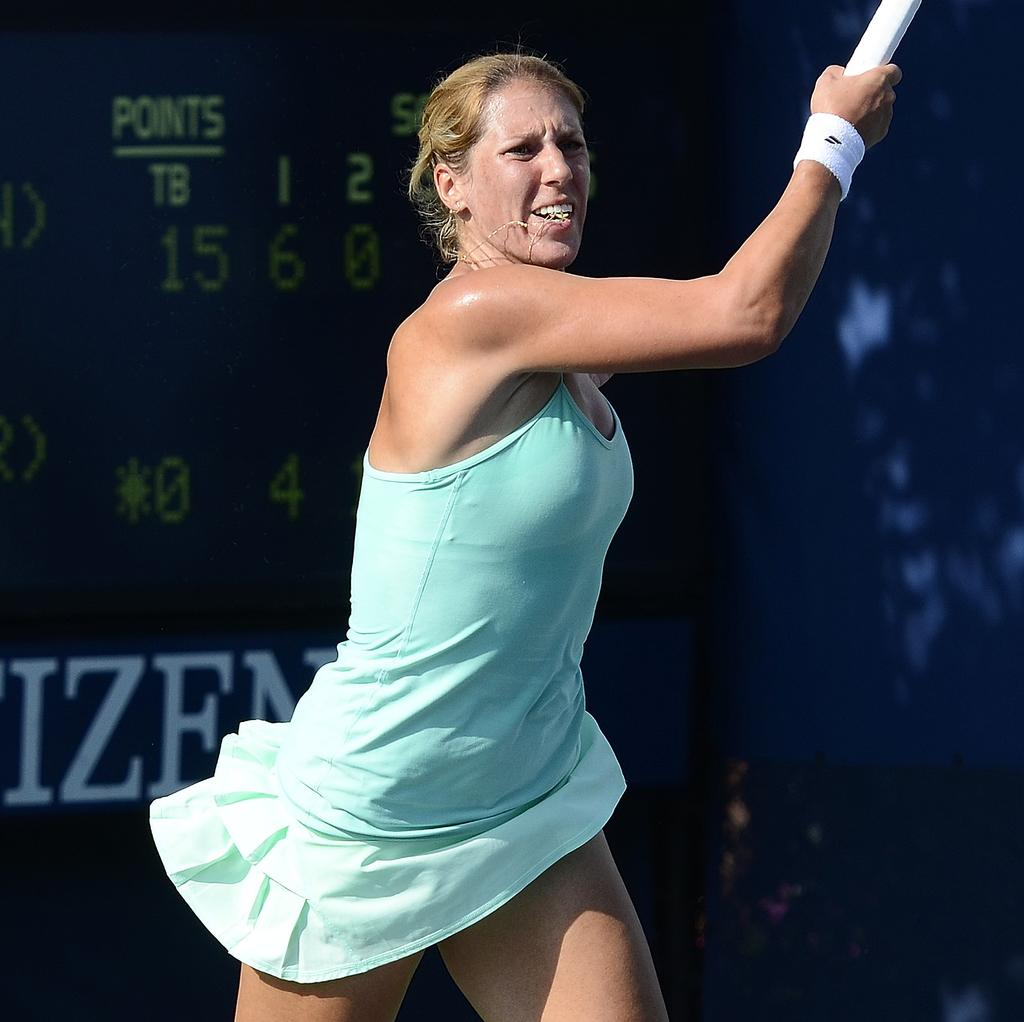What is the main subject of the image? There is a woman standing in the image. Where is the woman positioned in the image? The woman is in the middle of the image. What can be seen behind the woman? There is a banner behind the woman. How many eyes can be seen on the woman's bath roll in the image? There is no bath roll or any reference to eyes in the image; it features a woman standing with a banner behind her. 